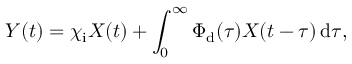<formula> <loc_0><loc_0><loc_500><loc_500>Y ( t ) = \chi _ { i } X ( t ) + \int _ { 0 } ^ { \infty } \Phi _ { d } ( \tau ) X ( t - \tau ) \, d \tau ,</formula> 